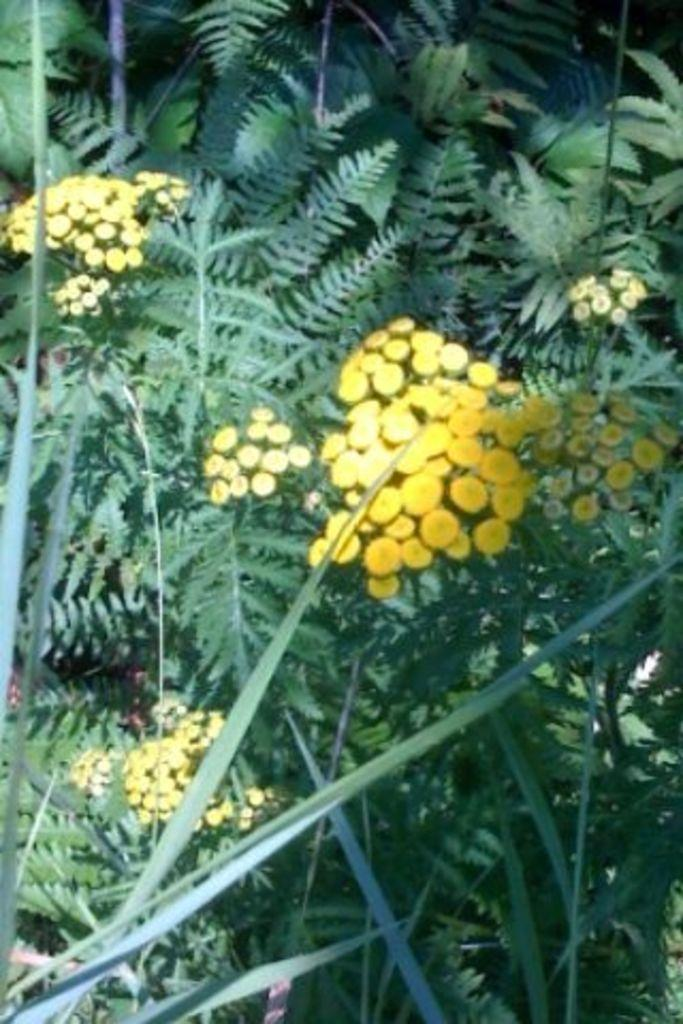What type of flora can be seen in the image? There are flowers and plants in the image. What other elements are present in the image besides the flora? There are many leaves in the image. How many chairs are visible in the image? There are no chairs present in the image; it features flowers, plants, and leaves. 